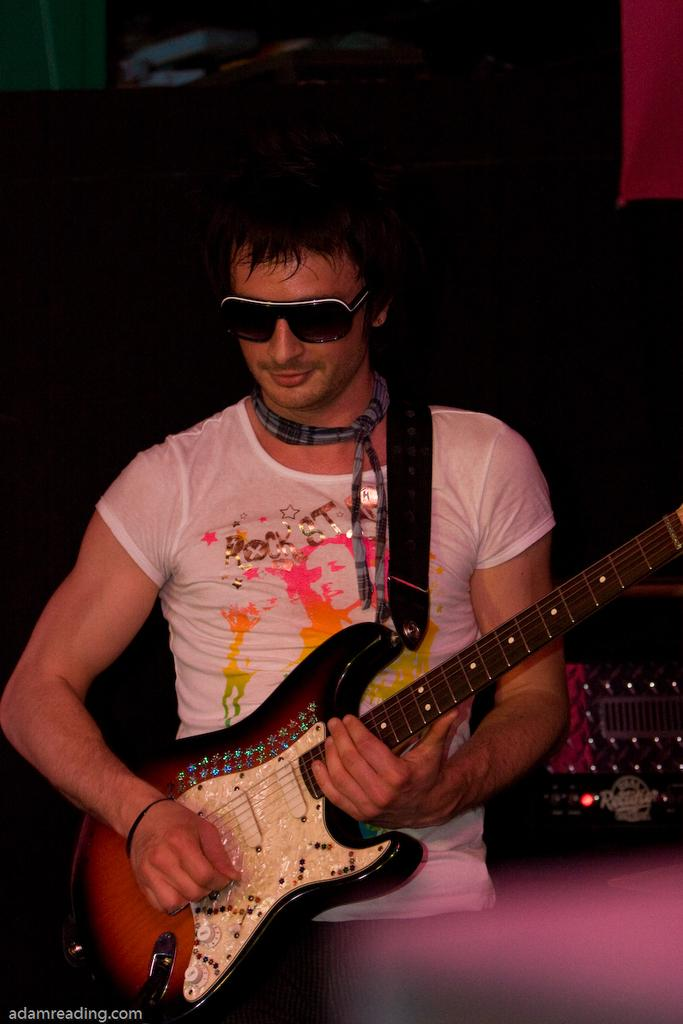Who is the main subject in the image? There is a man in the image. What is the man wearing? The man is wearing a white t-shirt. What is the man doing in the image? The man is playing a guitar. What can be seen in the background of the image? There are lights visible in the background of the image. What type of appliance can be seen in the image? There is no appliance present in the image. Is the man in the image located in a hospital? There is no indication in the image that the man is in a hospital. 